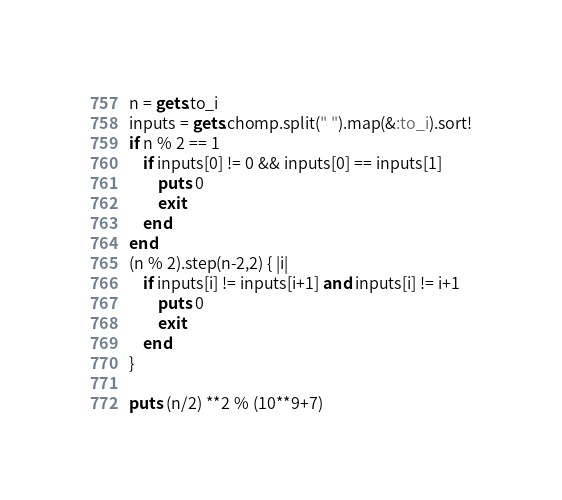<code> <loc_0><loc_0><loc_500><loc_500><_Ruby_>n = gets.to_i
inputs = gets.chomp.split(" ").map(&:to_i).sort!
if n % 2 == 1
	if inputs[0] != 0 && inputs[0] == inputs[1]  
		puts 0
		exit
	end
end
(n % 2).step(n-2,2) { |i|
	if inputs[i] != inputs[i+1] and inputs[i] != i+1
		puts 0
		exit
	end
}

puts (n/2) **2 % (10**9+7)

</code> 